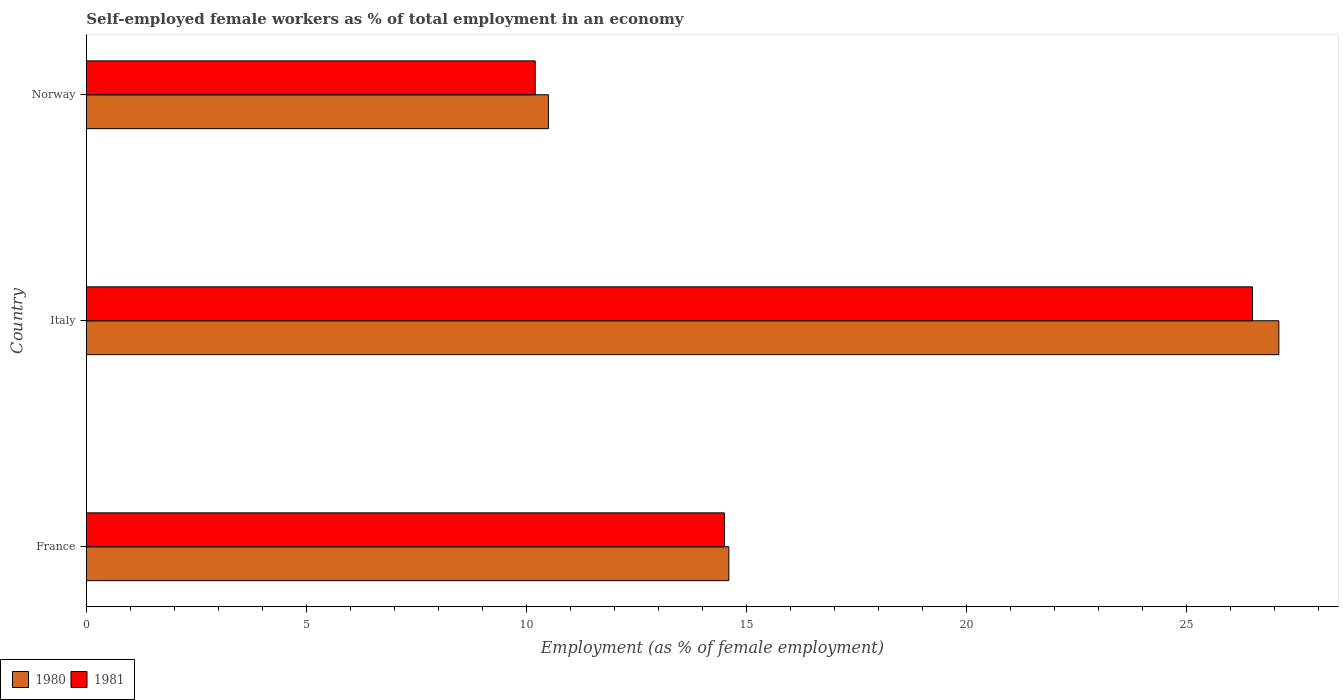How many different coloured bars are there?
Provide a succinct answer. 2. How many groups of bars are there?
Your answer should be very brief. 3. Are the number of bars per tick equal to the number of legend labels?
Offer a terse response. Yes. How many bars are there on the 3rd tick from the top?
Keep it short and to the point. 2. In how many cases, is the number of bars for a given country not equal to the number of legend labels?
Your answer should be very brief. 0. Across all countries, what is the maximum percentage of self-employed female workers in 1981?
Your response must be concise. 26.5. Across all countries, what is the minimum percentage of self-employed female workers in 1980?
Make the answer very short. 10.5. In which country was the percentage of self-employed female workers in 1980 maximum?
Provide a short and direct response. Italy. What is the total percentage of self-employed female workers in 1981 in the graph?
Offer a terse response. 51.2. What is the difference between the percentage of self-employed female workers in 1980 in Italy and the percentage of self-employed female workers in 1981 in France?
Provide a succinct answer. 12.6. What is the average percentage of self-employed female workers in 1980 per country?
Provide a short and direct response. 17.4. What is the difference between the percentage of self-employed female workers in 1980 and percentage of self-employed female workers in 1981 in Norway?
Your answer should be compact. 0.3. In how many countries, is the percentage of self-employed female workers in 1980 greater than 11 %?
Your answer should be compact. 2. What is the ratio of the percentage of self-employed female workers in 1980 in France to that in Norway?
Ensure brevity in your answer.  1.39. What is the difference between the highest and the second highest percentage of self-employed female workers in 1980?
Your answer should be very brief. 12.5. What is the difference between the highest and the lowest percentage of self-employed female workers in 1981?
Make the answer very short. 16.3. What does the 2nd bar from the top in Norway represents?
Your response must be concise. 1980. What does the 2nd bar from the bottom in Norway represents?
Ensure brevity in your answer.  1981. How many bars are there?
Provide a succinct answer. 6. Are all the bars in the graph horizontal?
Provide a succinct answer. Yes. Are the values on the major ticks of X-axis written in scientific E-notation?
Provide a succinct answer. No. What is the title of the graph?
Provide a succinct answer. Self-employed female workers as % of total employment in an economy. What is the label or title of the X-axis?
Keep it short and to the point. Employment (as % of female employment). What is the label or title of the Y-axis?
Ensure brevity in your answer.  Country. What is the Employment (as % of female employment) of 1980 in France?
Your answer should be very brief. 14.6. What is the Employment (as % of female employment) in 1980 in Italy?
Your response must be concise. 27.1. What is the Employment (as % of female employment) of 1981 in Italy?
Your answer should be very brief. 26.5. What is the Employment (as % of female employment) of 1980 in Norway?
Your answer should be very brief. 10.5. What is the Employment (as % of female employment) of 1981 in Norway?
Offer a terse response. 10.2. Across all countries, what is the maximum Employment (as % of female employment) in 1980?
Ensure brevity in your answer.  27.1. Across all countries, what is the minimum Employment (as % of female employment) in 1981?
Give a very brief answer. 10.2. What is the total Employment (as % of female employment) of 1980 in the graph?
Offer a very short reply. 52.2. What is the total Employment (as % of female employment) of 1981 in the graph?
Offer a terse response. 51.2. What is the difference between the Employment (as % of female employment) in 1980 in France and that in Italy?
Your answer should be very brief. -12.5. What is the difference between the Employment (as % of female employment) in 1980 in Italy and that in Norway?
Give a very brief answer. 16.6. What is the difference between the Employment (as % of female employment) in 1980 in France and the Employment (as % of female employment) in 1981 in Italy?
Your answer should be very brief. -11.9. What is the average Employment (as % of female employment) of 1981 per country?
Offer a terse response. 17.07. What is the difference between the Employment (as % of female employment) of 1980 and Employment (as % of female employment) of 1981 in Italy?
Ensure brevity in your answer.  0.6. What is the difference between the Employment (as % of female employment) in 1980 and Employment (as % of female employment) in 1981 in Norway?
Provide a succinct answer. 0.3. What is the ratio of the Employment (as % of female employment) in 1980 in France to that in Italy?
Offer a very short reply. 0.54. What is the ratio of the Employment (as % of female employment) in 1981 in France to that in Italy?
Ensure brevity in your answer.  0.55. What is the ratio of the Employment (as % of female employment) of 1980 in France to that in Norway?
Give a very brief answer. 1.39. What is the ratio of the Employment (as % of female employment) in 1981 in France to that in Norway?
Provide a short and direct response. 1.42. What is the ratio of the Employment (as % of female employment) of 1980 in Italy to that in Norway?
Your answer should be compact. 2.58. What is the ratio of the Employment (as % of female employment) of 1981 in Italy to that in Norway?
Keep it short and to the point. 2.6. What is the difference between the highest and the second highest Employment (as % of female employment) of 1980?
Make the answer very short. 12.5. What is the difference between the highest and the second highest Employment (as % of female employment) of 1981?
Ensure brevity in your answer.  12. What is the difference between the highest and the lowest Employment (as % of female employment) of 1981?
Provide a succinct answer. 16.3. 